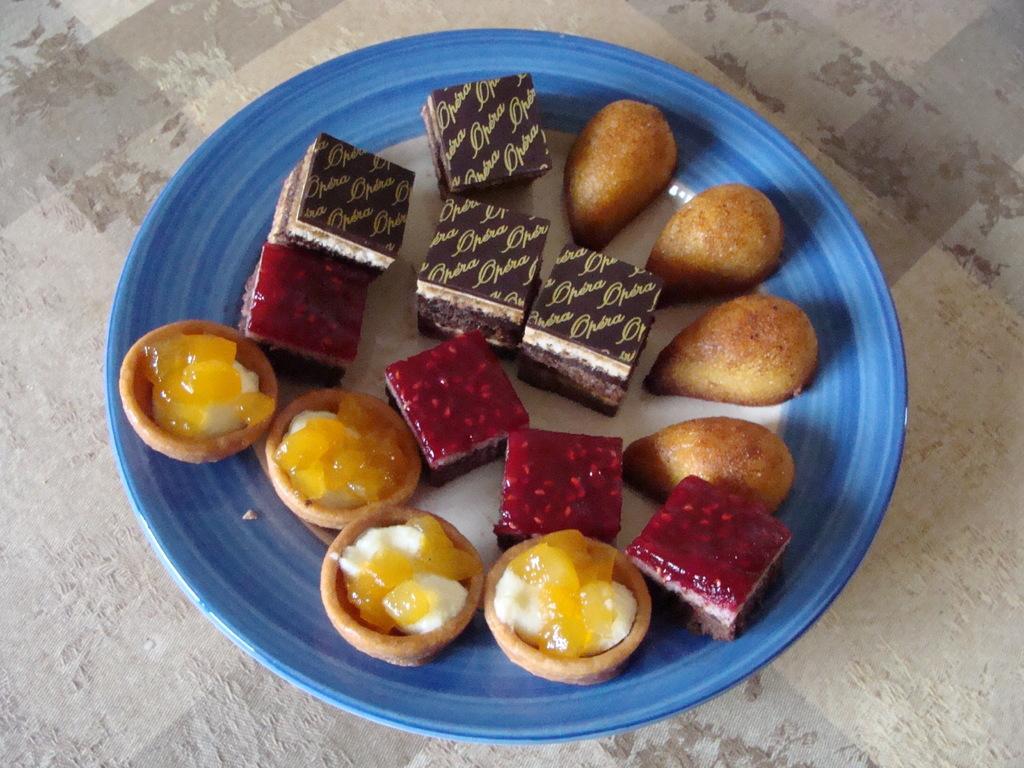In one or two sentences, can you explain what this image depicts? In this image I can see the cream colored surface and on it I can see a plate which is white and blue in color. On the plate I can see few food items which are black, brown, orange, red , yellow and white in color. 